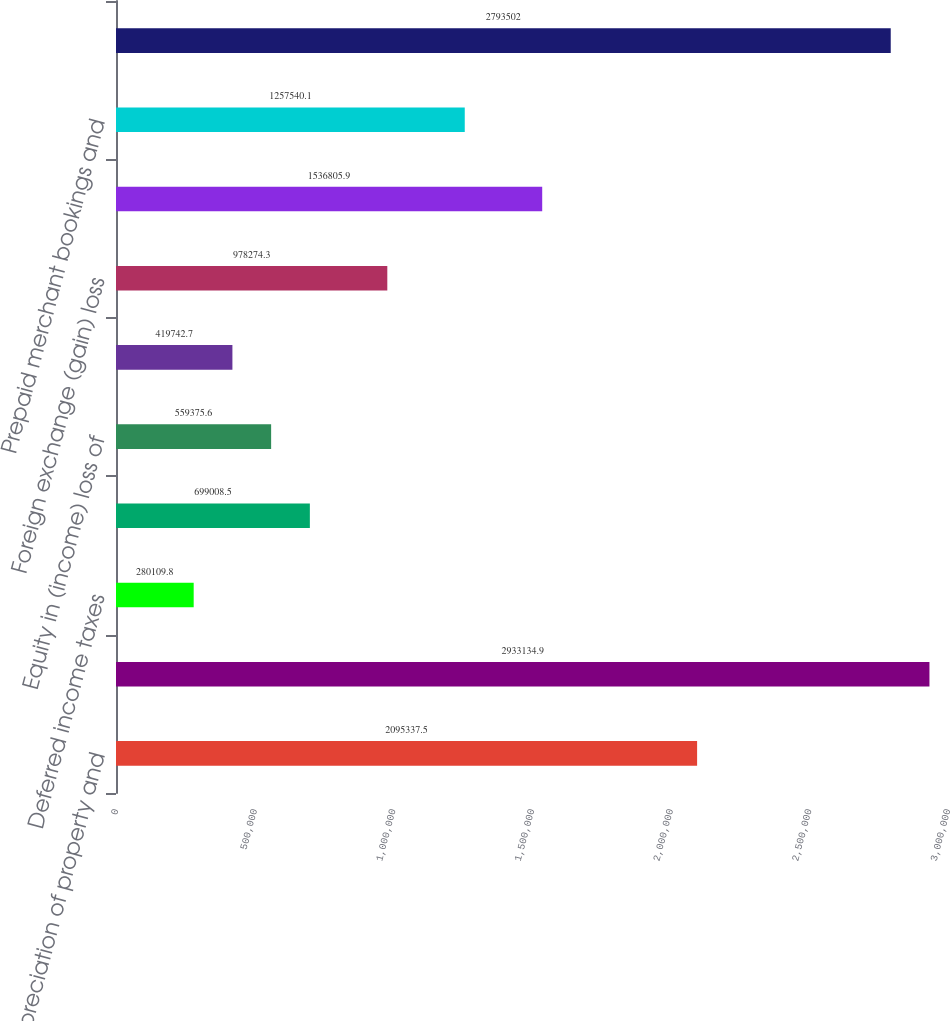Convert chart to OTSL. <chart><loc_0><loc_0><loc_500><loc_500><bar_chart><fcel>Depreciation of property and<fcel>Amortization of intangible<fcel>Deferred income taxes<fcel>(Gain) loss on derivative<fcel>Equity in (income) loss of<fcel>Minority interest in income<fcel>Foreign exchange (gain) loss<fcel>Accounts receivable<fcel>Prepaid merchant bookings and<fcel>Accounts payable merchant<nl><fcel>2.09534e+06<fcel>2.93313e+06<fcel>280110<fcel>699008<fcel>559376<fcel>419743<fcel>978274<fcel>1.53681e+06<fcel>1.25754e+06<fcel>2.7935e+06<nl></chart> 